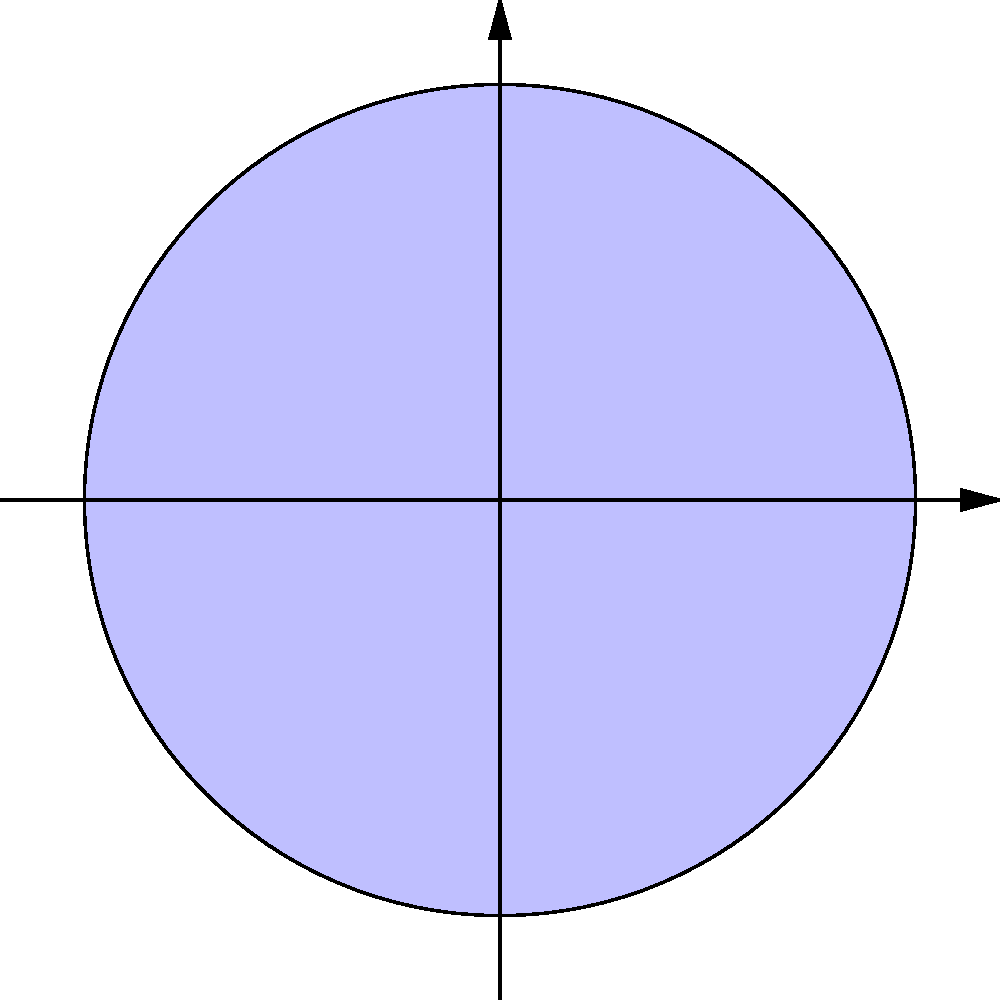As a politician advocating for improved science education in Gombe State, you're explaining the Earth's rotation and day/night cycle to a group of students. Using the illustration provided, which shows the Earth, its axis, and the Sun, explain why different parts of the Earth experience day and night at different times. How does this relate to the concept of time zones? To explain the Earth's rotation and day/night cycle:

1. Earth's rotation: The blue arrow in the image represents the Earth's rotation on its axis, which takes approximately 24 hours to complete one full rotation.

2. Light source: The Sun, shown as the yellow circle on the right, emits light rays (dashed yellow lines) that illuminate half of the Earth at any given time.

3. Day and night: The side of the Earth facing the Sun experiences daylight, while the opposite side is in darkness (night).

4. Continuous rotation: As the Earth rotates, different parts of its surface face the Sun, creating a cycle of day and night for each location.

5. Time zones: Due to this rotation, different parts of the Earth experience sunrise and sunset at different times. This led to the creation of time zones.

6. Local noon: When a specific location on Earth directly faces the Sun, it experiences local noon.

7. Gombe State perspective: Gombe State, like other parts of Nigeria, experiences this day/night cycle as the Earth rotates, with sunrise occurring earlier than in countries to the west and later than those to the east.

8. Global impact: This rotation affects global activities, international communications, and travel planning, which is crucial for politicians dealing with international affairs.

Understanding this concept is essential for making informed decisions about policies related to agriculture, energy use, and international relations.
Answer: Earth's rotation causes different parts to face the Sun at different times, creating day/night cycles and time zones. 